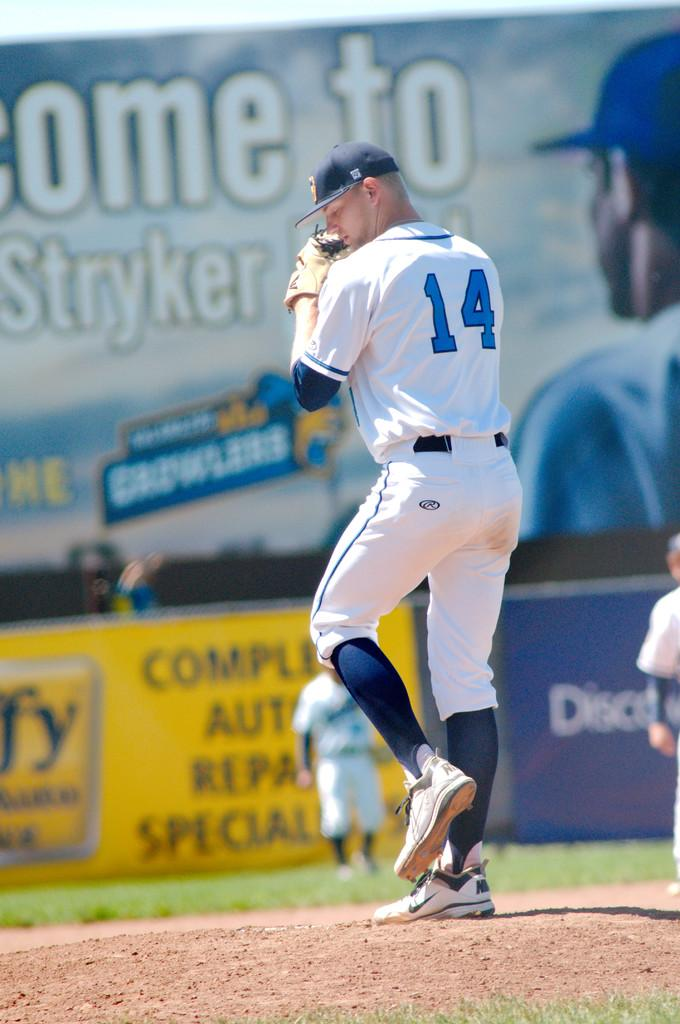<image>
Give a short and clear explanation of the subsequent image. A baseball player getting ready to pitch with Stryker advertising in the back. 